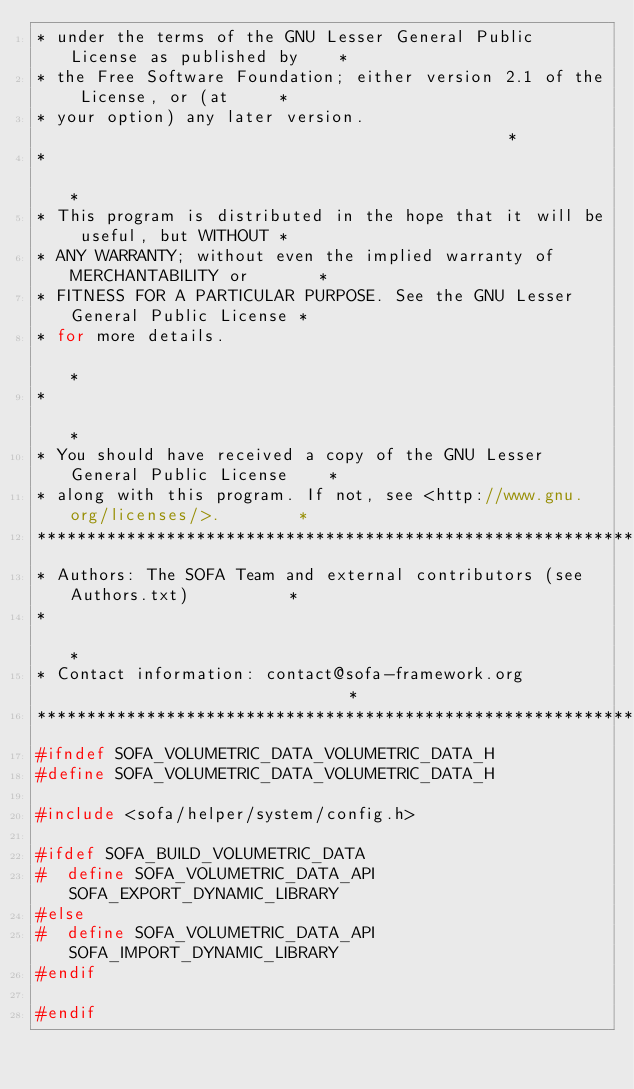Convert code to text. <code><loc_0><loc_0><loc_500><loc_500><_C_>* under the terms of the GNU Lesser General Public License as published by    *
* the Free Software Foundation; either version 2.1 of the License, or (at     *
* your option) any later version.                                             *
*                                                                             *
* This program is distributed in the hope that it will be useful, but WITHOUT *
* ANY WARRANTY; without even the implied warranty of MERCHANTABILITY or       *
* FITNESS FOR A PARTICULAR PURPOSE. See the GNU Lesser General Public License *
* for more details.                                                           *
*                                                                             *
* You should have received a copy of the GNU Lesser General Public License    *
* along with this program. If not, see <http://www.gnu.org/licenses/>.        *
*******************************************************************************
* Authors: The SOFA Team and external contributors (see Authors.txt)          *
*                                                                             *
* Contact information: contact@sofa-framework.org                             *
******************************************************************************/
#ifndef SOFA_VOLUMETRIC_DATA_VOLUMETRIC_DATA_H
#define SOFA_VOLUMETRIC_DATA_VOLUMETRIC_DATA_H

#include <sofa/helper/system/config.h>

#ifdef SOFA_BUILD_VOLUMETRIC_DATA
#  define SOFA_VOLUMETRIC_DATA_API SOFA_EXPORT_DYNAMIC_LIBRARY
#else
#  define SOFA_VOLUMETRIC_DATA_API SOFA_IMPORT_DYNAMIC_LIBRARY
#endif

#endif
</code> 